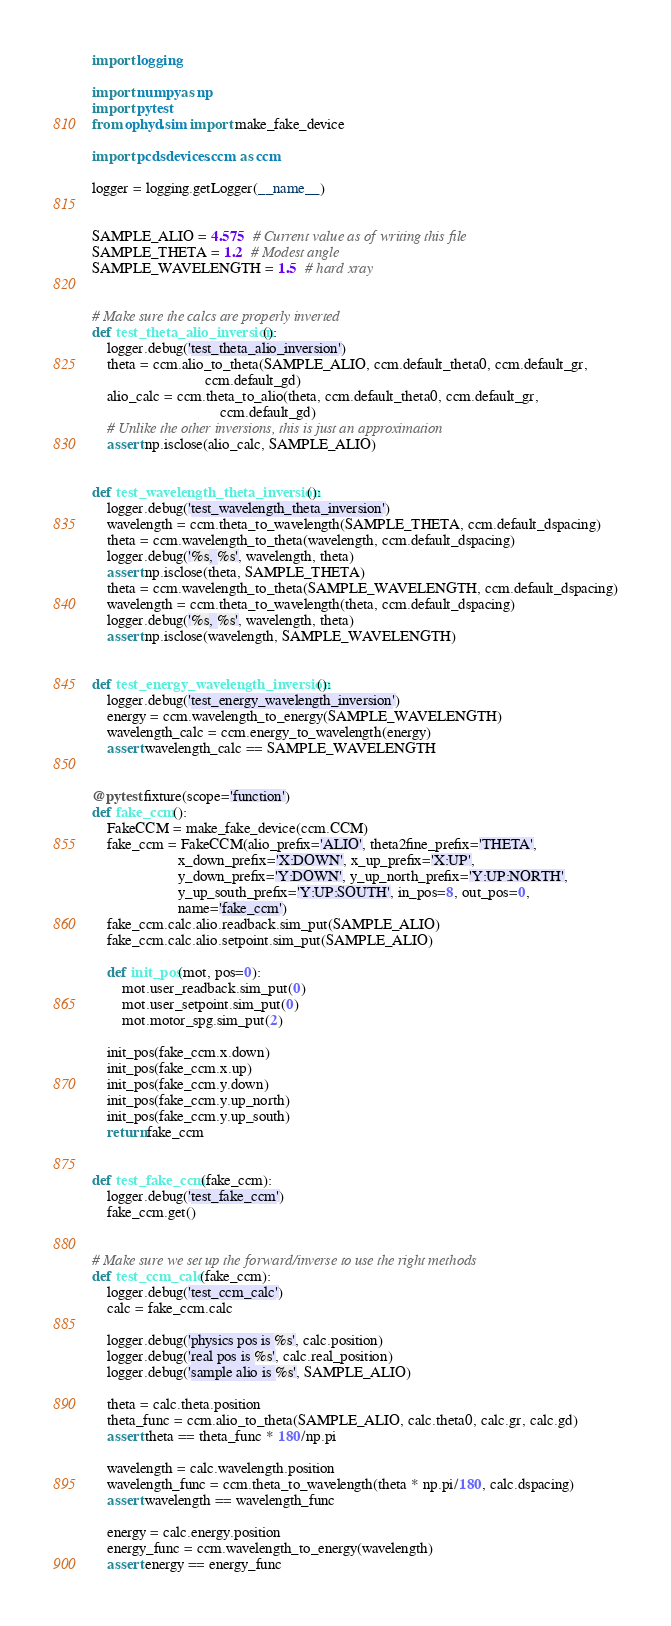<code> <loc_0><loc_0><loc_500><loc_500><_Python_>import logging

import numpy as np
import pytest
from ophyd.sim import make_fake_device

import pcdsdevices.ccm as ccm

logger = logging.getLogger(__name__)


SAMPLE_ALIO = 4.575  # Current value as of writing this file
SAMPLE_THETA = 1.2  # Modest angle
SAMPLE_WAVELENGTH = 1.5  # hard xray


# Make sure the calcs are properly inverted
def test_theta_alio_inversion():
    logger.debug('test_theta_alio_inversion')
    theta = ccm.alio_to_theta(SAMPLE_ALIO, ccm.default_theta0, ccm.default_gr,
                              ccm.default_gd)
    alio_calc = ccm.theta_to_alio(theta, ccm.default_theta0, ccm.default_gr,
                                  ccm.default_gd)
    # Unlike the other inversions, this is just an approximation
    assert np.isclose(alio_calc, SAMPLE_ALIO)


def test_wavelength_theta_inversion():
    logger.debug('test_wavelength_theta_inversion')
    wavelength = ccm.theta_to_wavelength(SAMPLE_THETA, ccm.default_dspacing)
    theta = ccm.wavelength_to_theta(wavelength, ccm.default_dspacing)
    logger.debug('%s, %s', wavelength, theta)
    assert np.isclose(theta, SAMPLE_THETA)
    theta = ccm.wavelength_to_theta(SAMPLE_WAVELENGTH, ccm.default_dspacing)
    wavelength = ccm.theta_to_wavelength(theta, ccm.default_dspacing)
    logger.debug('%s, %s', wavelength, theta)
    assert np.isclose(wavelength, SAMPLE_WAVELENGTH)


def test_energy_wavelength_inversion():
    logger.debug('test_energy_wavelength_inversion')
    energy = ccm.wavelength_to_energy(SAMPLE_WAVELENGTH)
    wavelength_calc = ccm.energy_to_wavelength(energy)
    assert wavelength_calc == SAMPLE_WAVELENGTH


@pytest.fixture(scope='function')
def fake_ccm():
    FakeCCM = make_fake_device(ccm.CCM)
    fake_ccm = FakeCCM(alio_prefix='ALIO', theta2fine_prefix='THETA',
                       x_down_prefix='X:DOWN', x_up_prefix='X:UP',
                       y_down_prefix='Y:DOWN', y_up_north_prefix='Y:UP:NORTH',
                       y_up_south_prefix='Y:UP:SOUTH', in_pos=8, out_pos=0,
                       name='fake_ccm')
    fake_ccm.calc.alio.readback.sim_put(SAMPLE_ALIO)
    fake_ccm.calc.alio.setpoint.sim_put(SAMPLE_ALIO)

    def init_pos(mot, pos=0):
        mot.user_readback.sim_put(0)
        mot.user_setpoint.sim_put(0)
        mot.motor_spg.sim_put(2)

    init_pos(fake_ccm.x.down)
    init_pos(fake_ccm.x.up)
    init_pos(fake_ccm.y.down)
    init_pos(fake_ccm.y.up_north)
    init_pos(fake_ccm.y.up_south)
    return fake_ccm


def test_fake_ccm(fake_ccm):
    logger.debug('test_fake_ccm')
    fake_ccm.get()


# Make sure we set up the forward/inverse to use the right methods
def test_ccm_calc(fake_ccm):
    logger.debug('test_ccm_calc')
    calc = fake_ccm.calc

    logger.debug('physics pos is %s', calc.position)
    logger.debug('real pos is %s', calc.real_position)
    logger.debug('sample alio is %s', SAMPLE_ALIO)

    theta = calc.theta.position
    theta_func = ccm.alio_to_theta(SAMPLE_ALIO, calc.theta0, calc.gr, calc.gd)
    assert theta == theta_func * 180/np.pi

    wavelength = calc.wavelength.position
    wavelength_func = ccm.theta_to_wavelength(theta * np.pi/180, calc.dspacing)
    assert wavelength == wavelength_func

    energy = calc.energy.position
    energy_func = ccm.wavelength_to_energy(wavelength)
    assert energy == energy_func
</code> 